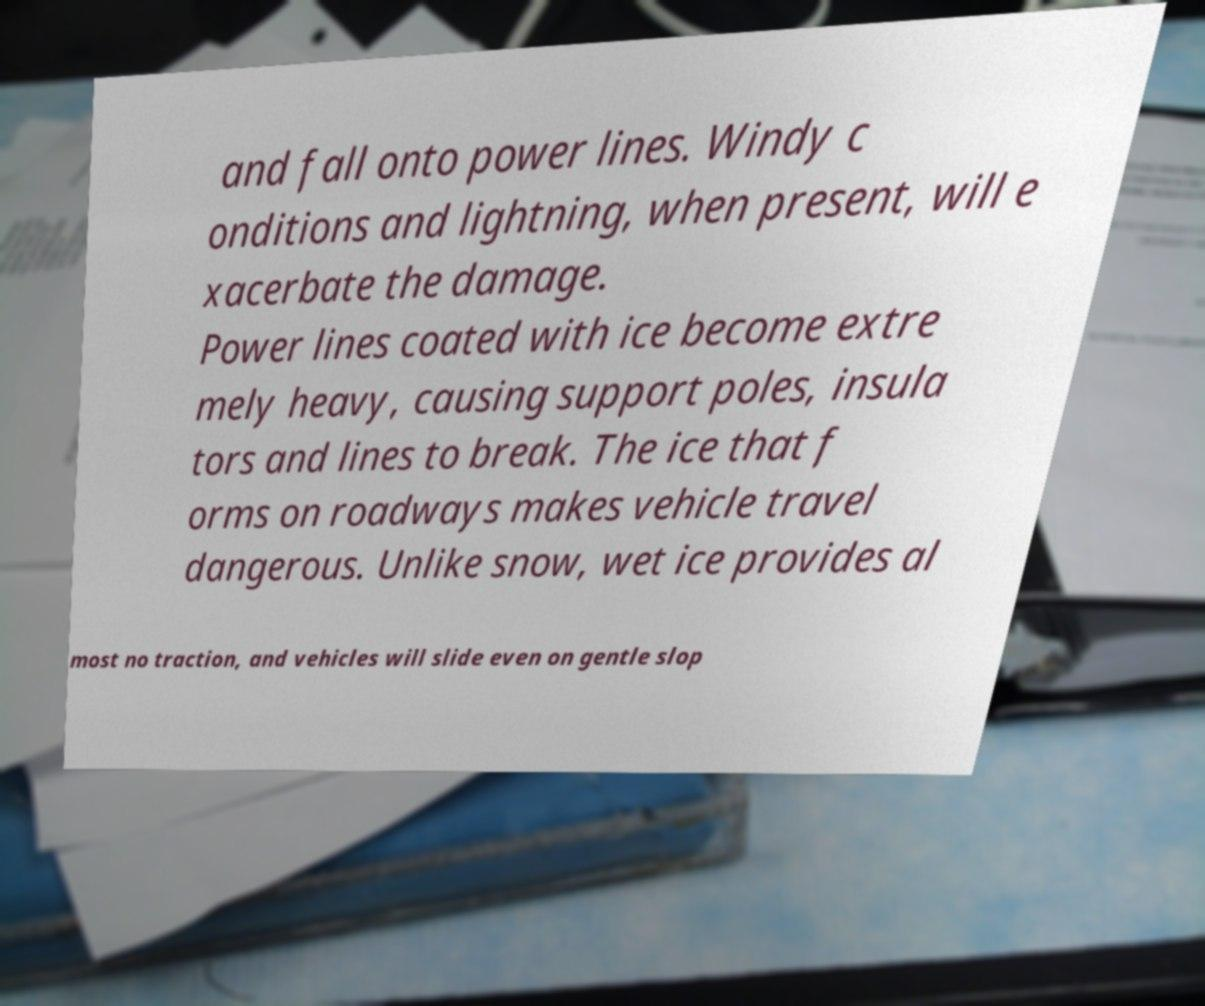Can you accurately transcribe the text from the provided image for me? and fall onto power lines. Windy c onditions and lightning, when present, will e xacerbate the damage. Power lines coated with ice become extre mely heavy, causing support poles, insula tors and lines to break. The ice that f orms on roadways makes vehicle travel dangerous. Unlike snow, wet ice provides al most no traction, and vehicles will slide even on gentle slop 